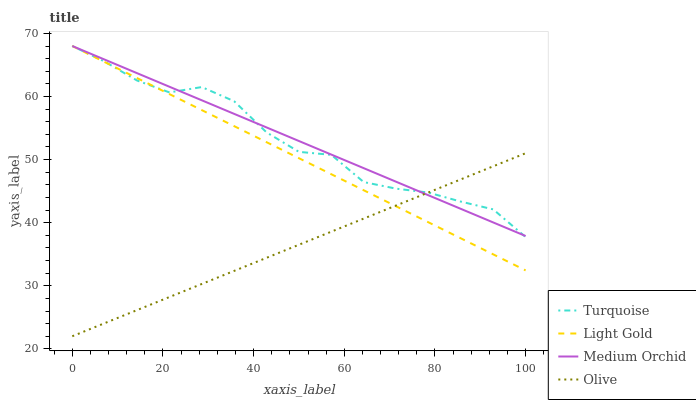Does Turquoise have the minimum area under the curve?
Answer yes or no. No. Does Turquoise have the maximum area under the curve?
Answer yes or no. No. Is Medium Orchid the smoothest?
Answer yes or no. No. Is Medium Orchid the roughest?
Answer yes or no. No. Does Turquoise have the lowest value?
Answer yes or no. No. 